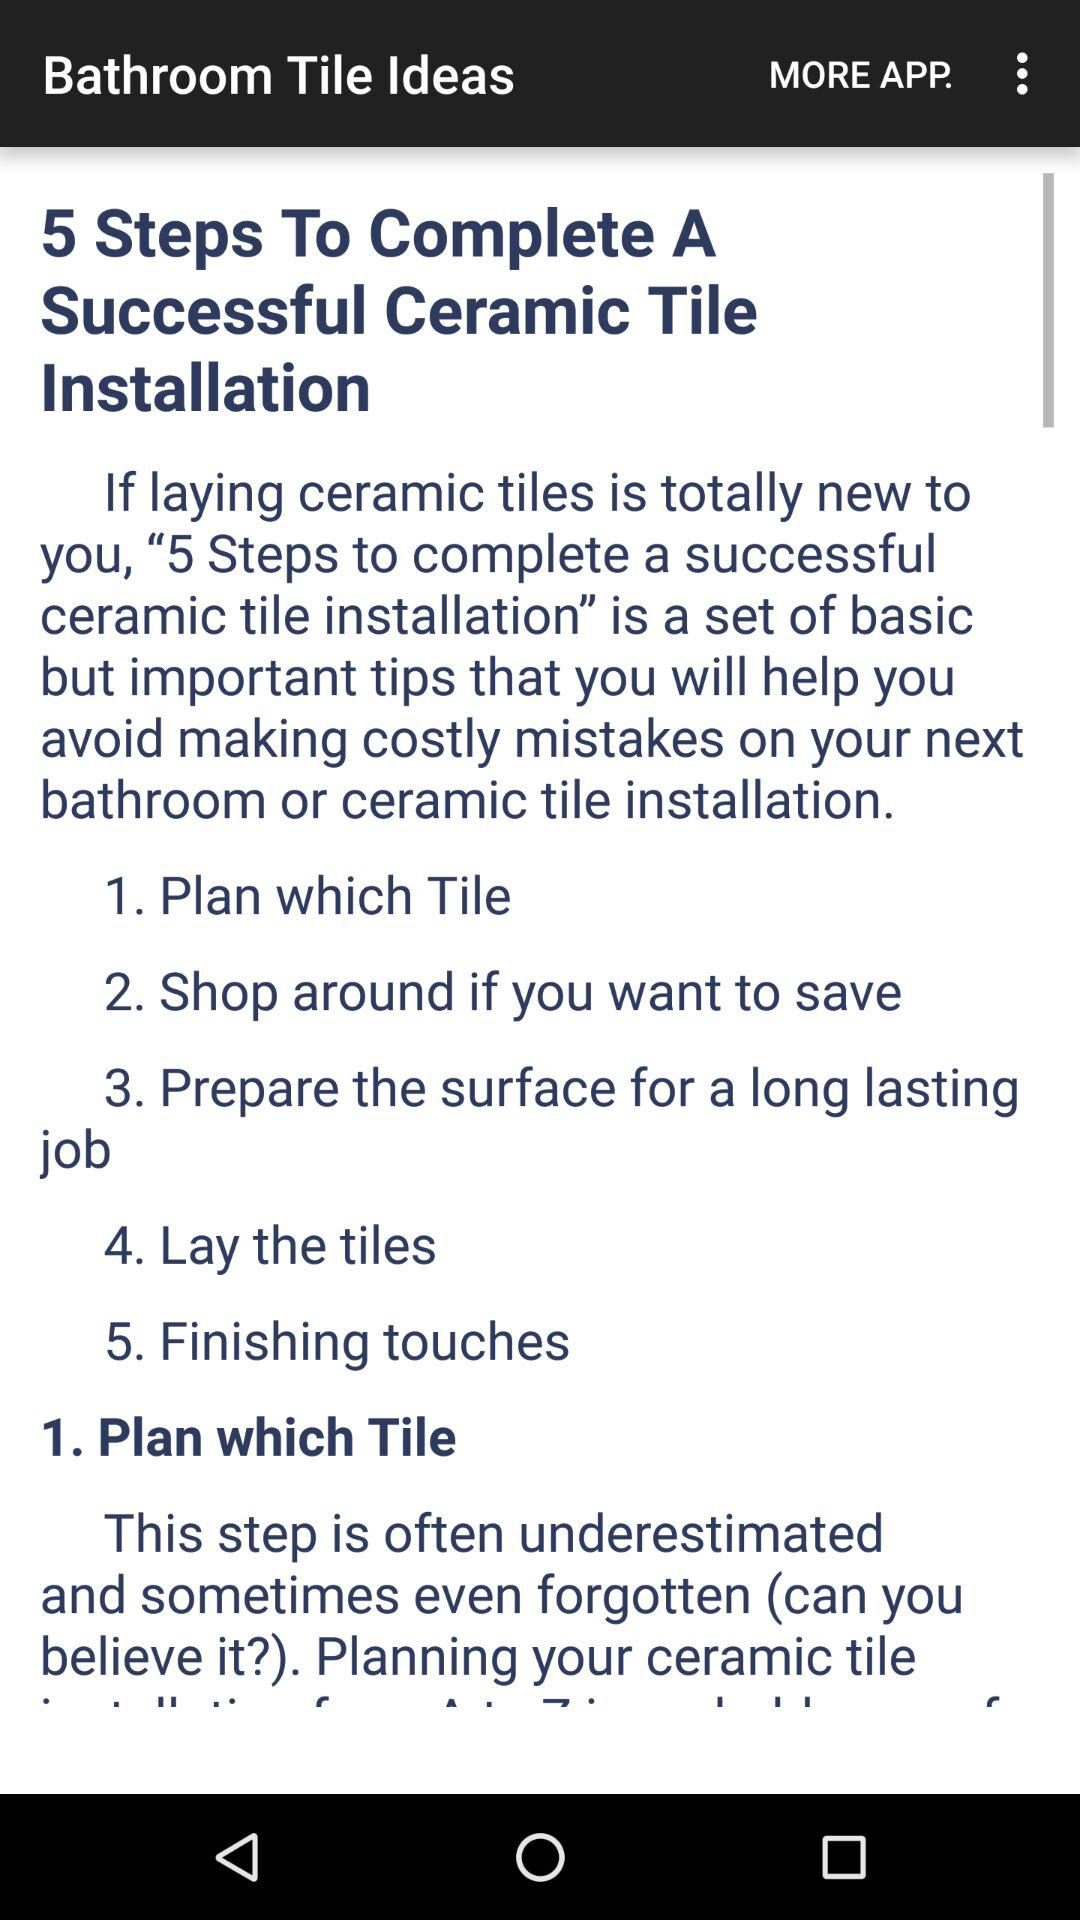How many steps are there in the guide?
Answer the question using a single word or phrase. 5 